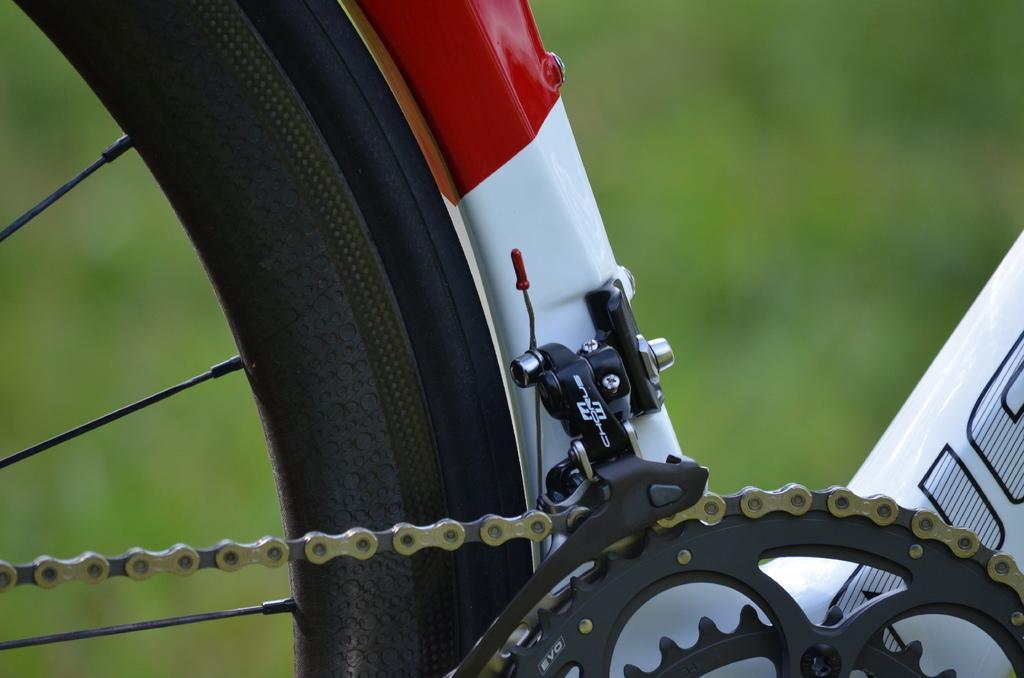Describe this image in one or two sentences. In this image we can see a part of the bicycle and we can see a wheel with chain. And blur background. 